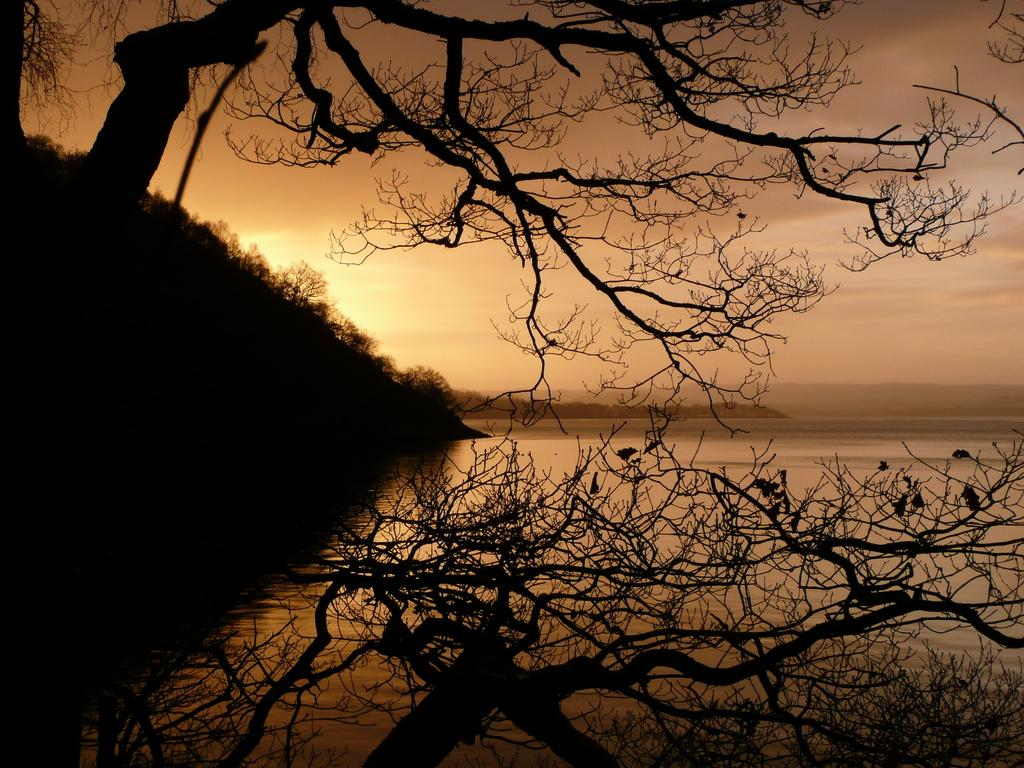What is visible in the image? Water is visible in the image. What type of vegetation can be seen in the image? There are trees in the image. What part of the natural environment is visible in the image? The sky is visible in the background of the image. What type of copper object can be seen at the edge of the water in the image? There is no copper object present at the edge of the water in the image. What type of needle can be seen in the trees in the image? There is no needle present in the trees in the image. 